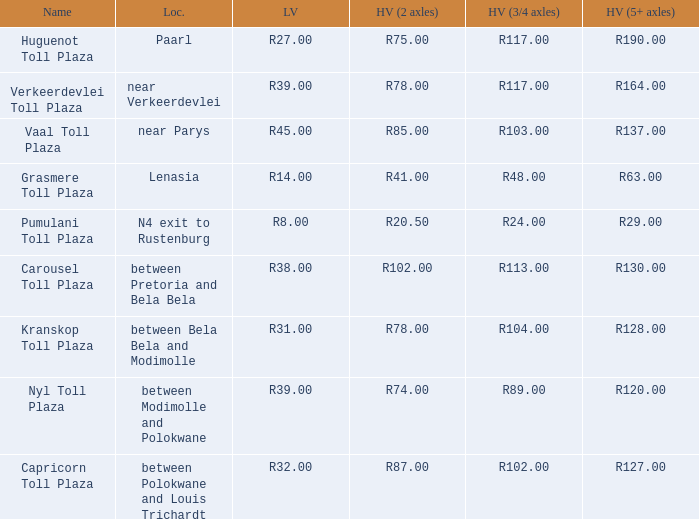What is the location of the Carousel toll plaza? Between pretoria and bela bela. 